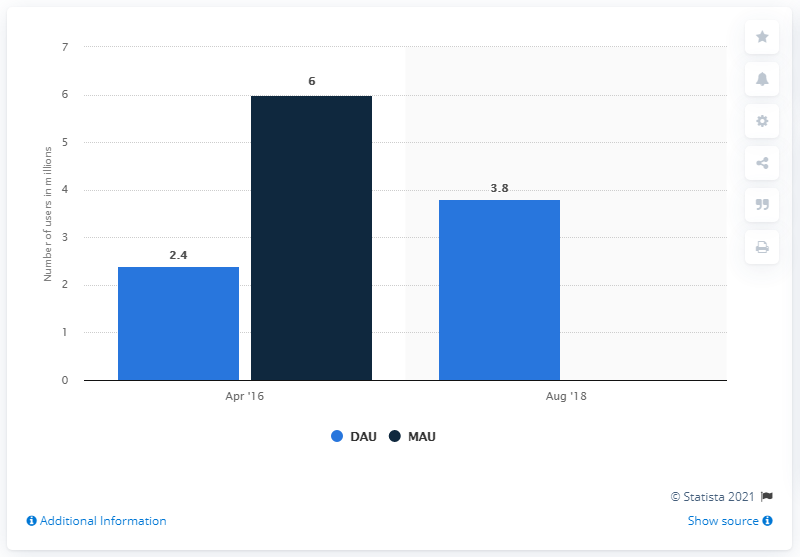Draw attention to some important aspects in this diagram. As of August 2018, Grindr had approximately 3.8 million users. 